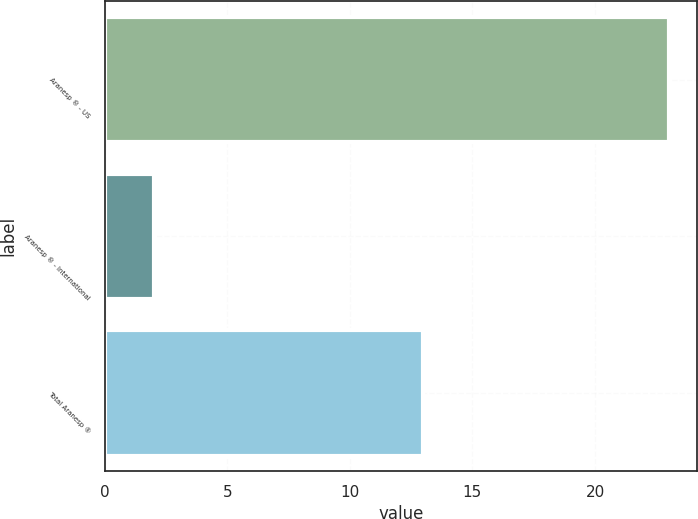Convert chart to OTSL. <chart><loc_0><loc_0><loc_500><loc_500><bar_chart><fcel>Aranesp ® - US<fcel>Aranesp ® - International<fcel>Total Aranesp ®<nl><fcel>23<fcel>2<fcel>13<nl></chart> 